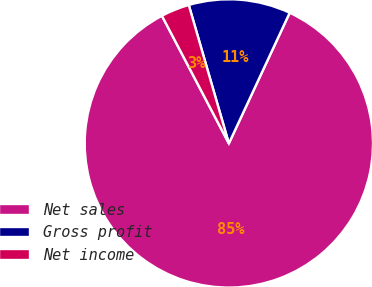<chart> <loc_0><loc_0><loc_500><loc_500><pie_chart><fcel>Net sales<fcel>Gross profit<fcel>Net income<nl><fcel>85.38%<fcel>11.42%<fcel>3.2%<nl></chart> 